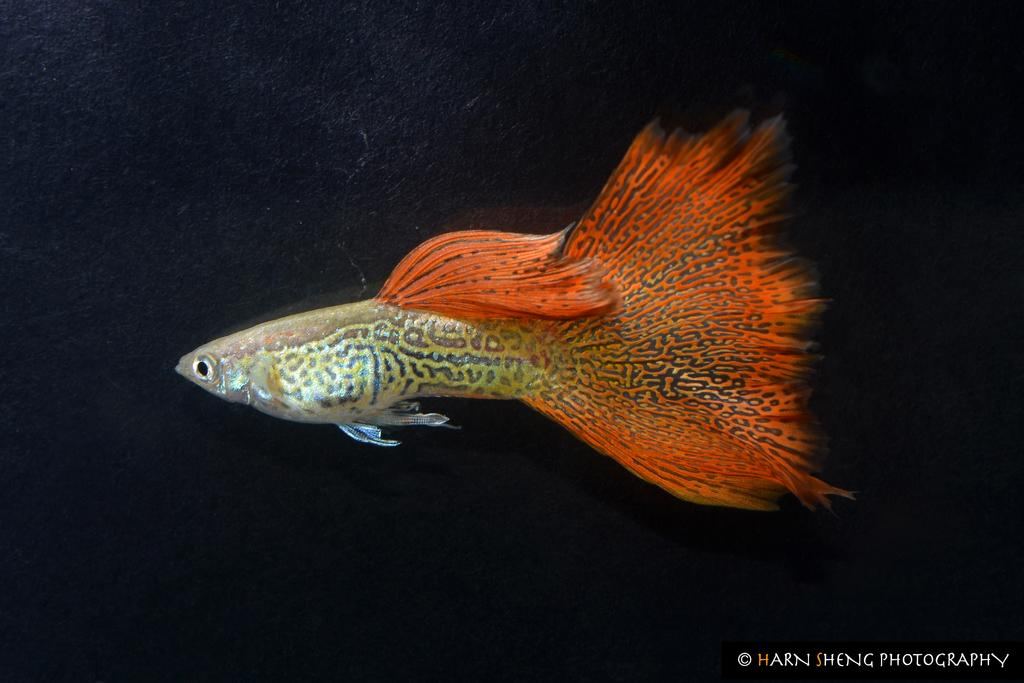What is the main subject of the image? There is a fish in the image. Can you describe the background of the image? The background of the image is dark. Is there any text present in the image? Yes, there is some text in the bottom right corner of the image. What type of flower is growing on the sidewalk in the image? There is no sidewalk or flower present in the image; it features a fish with a dark background and some text in the bottom right corner. 